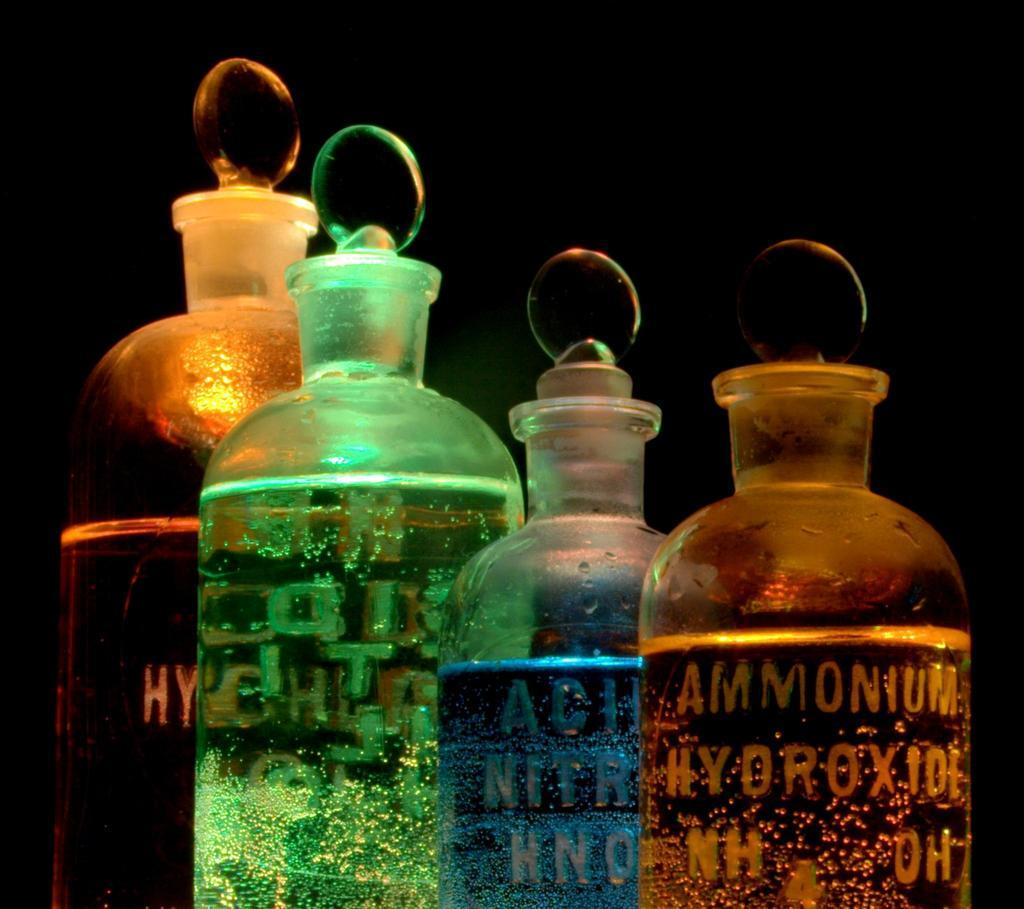<image>
Summarize the visual content of the image. A yellow bottle has "Ammonium" sketched on the side next to a blue bottle. 